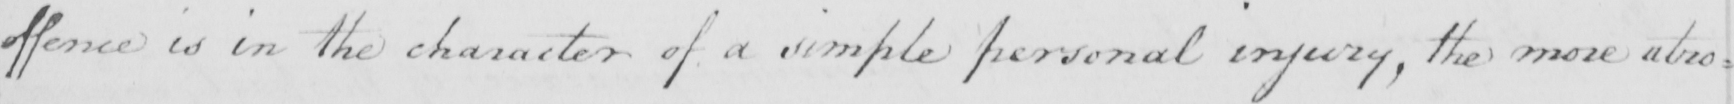Can you tell me what this handwritten text says? offence is in the character of a simple personal injury , the more atro= 